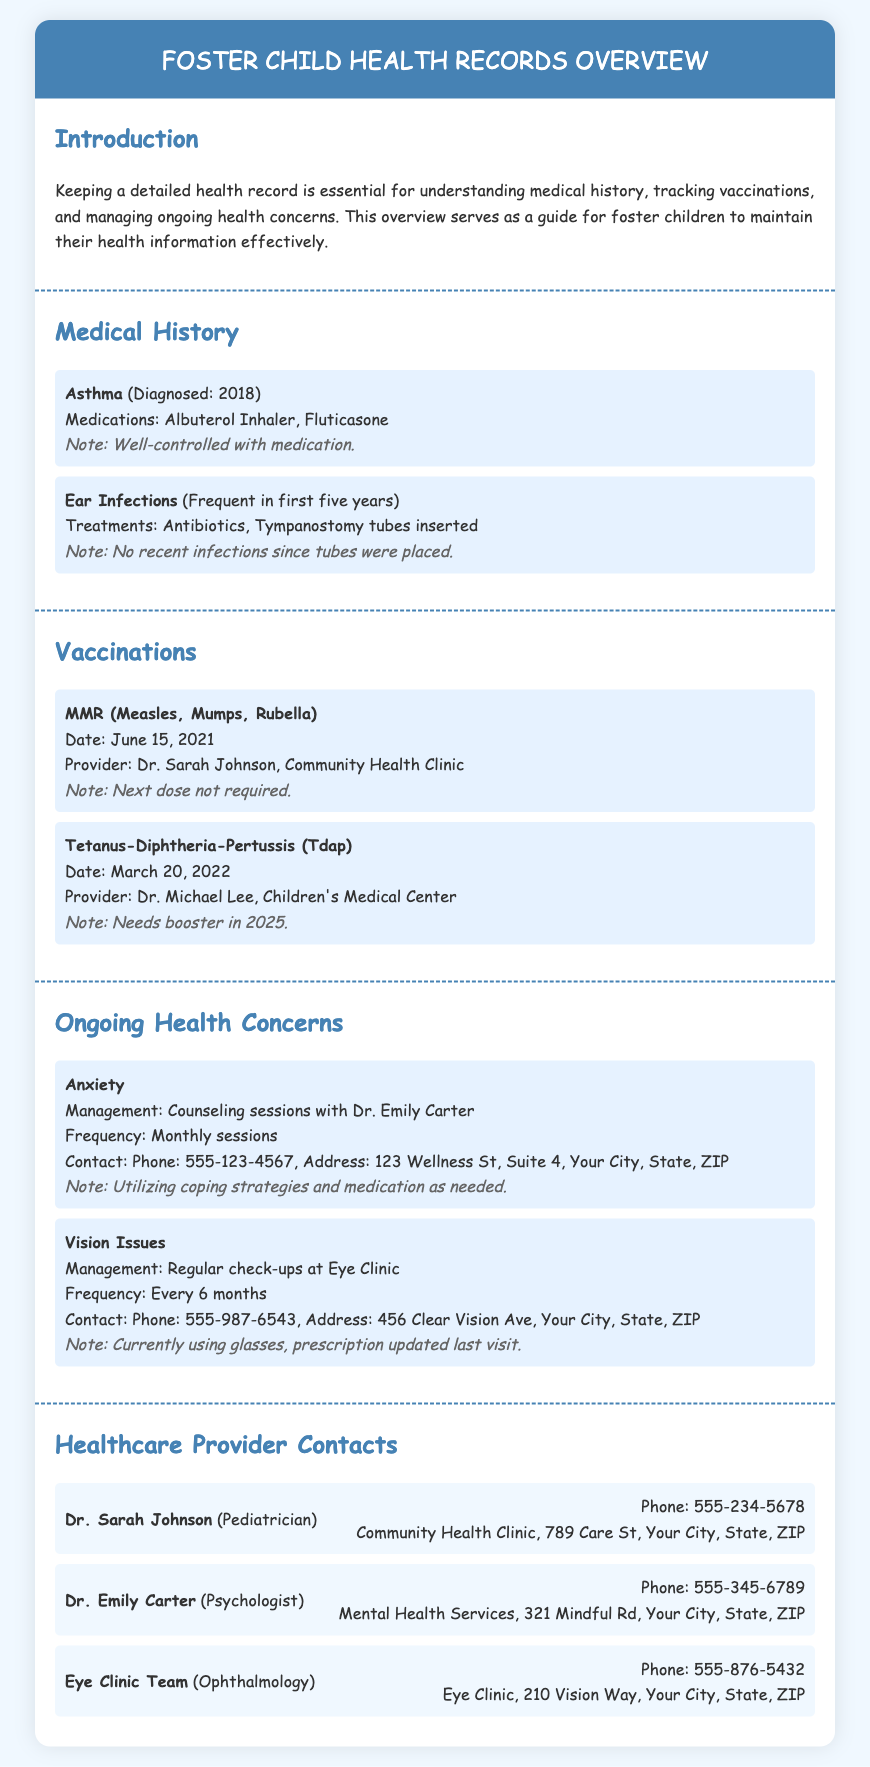What condition was diagnosed in 2018? The document states that Asthma was diagnosed in 2018 under the Medical History section.
Answer: Asthma What medications are used for asthma? The document lists Albuterol Inhaler and Fluticasone as medications for asthma.
Answer: Albuterol Inhaler, Fluticasone What date was the last MMR vaccination? The document specifies that the last MMR vaccination was on June 15, 2021.
Answer: June 15, 2021 How often are counseling sessions for anxiety? The document indicates that counseling sessions for anxiety are held monthly.
Answer: Monthly Who is the contact for vision issues? The document mentions the Eye Clinic as the contact for vision issues.
Answer: Eye Clinic What is the phone number for Dr. Emily Carter? The document provides the phone number for Dr. Emily Carter as 555-345-6789.
Answer: 555-345-6789 When is the next Tdap booster due? The document notes that the next Tdap booster is needed in 2025.
Answer: 2025 What healthcare provider deals with ophthalmology? The document states that the Eye Clinic Team handles ophthalmology.
Answer: Eye Clinic Team What ongoing health concern involves monthly sessions? The document indicates that anxiety is an ongoing health concern managed with monthly sessions.
Answer: Anxiety 